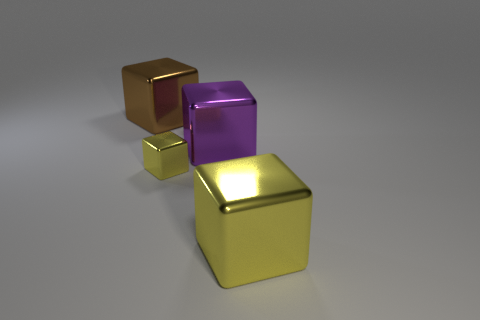Add 3 big yellow metallic cubes. How many objects exist? 7 Add 2 big purple things. How many big purple things are left? 3 Add 3 cyan objects. How many cyan objects exist? 3 Subtract 0 blue cylinders. How many objects are left? 4 Subtract all big green metal balls. Subtract all purple shiny things. How many objects are left? 3 